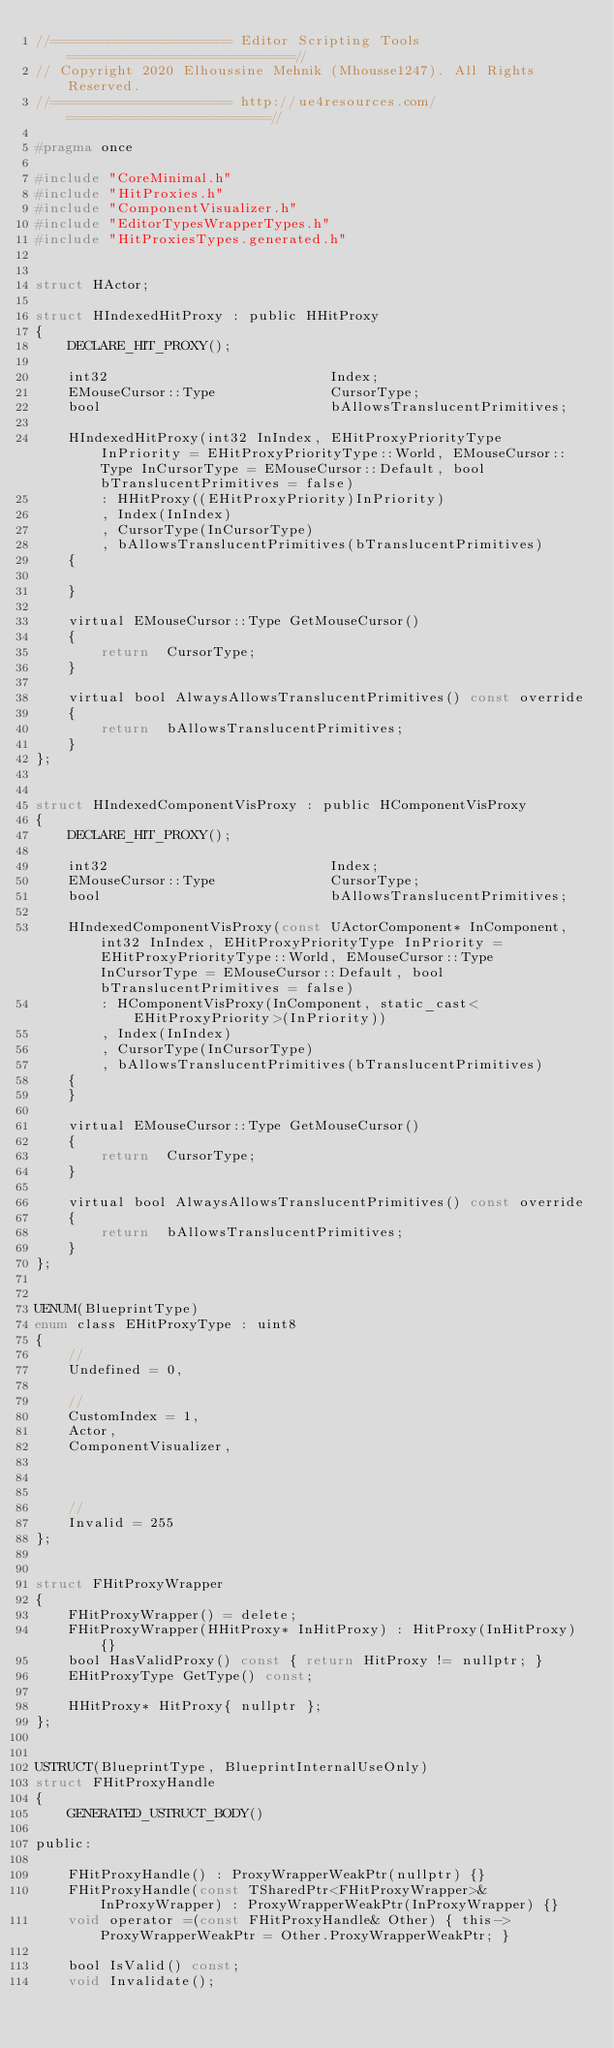Convert code to text. <code><loc_0><loc_0><loc_500><loc_500><_C_>//====================== Editor Scripting Tools ===========================//
// Copyright 2020 Elhoussine Mehnik (Mhousse1247). All Rights Reserved.
//====================== http://ue4resources.com/ ========================//

#pragma once

#include "CoreMinimal.h"
#include "HitProxies.h"
#include "ComponentVisualizer.h"
#include "EditorTypesWrapperTypes.h"
#include "HitProxiesTypes.generated.h"


struct HActor;

struct HIndexedHitProxy : public HHitProxy
{
	DECLARE_HIT_PROXY();

	int32							Index;
	EMouseCursor::Type				CursorType;
	bool							bAllowsTranslucentPrimitives;

	HIndexedHitProxy(int32 InIndex, EHitProxyPriorityType InPriority = EHitProxyPriorityType::World, EMouseCursor::Type InCursorType = EMouseCursor::Default, bool bTranslucentPrimitives = false)
		: HHitProxy((EHitProxyPriority)InPriority)
		, Index(InIndex)
		, CursorType(InCursorType)
		, bAllowsTranslucentPrimitives(bTranslucentPrimitives)
	{

	}

	virtual EMouseCursor::Type GetMouseCursor()
	{
		return  CursorType;
	}

	virtual bool AlwaysAllowsTranslucentPrimitives() const override
	{
		return  bAllowsTranslucentPrimitives;
	}
};


struct HIndexedComponentVisProxy : public HComponentVisProxy
{
	DECLARE_HIT_PROXY();

	int32							Index;
	EMouseCursor::Type				CursorType;
	bool							bAllowsTranslucentPrimitives;

	HIndexedComponentVisProxy(const UActorComponent* InComponent, int32 InIndex, EHitProxyPriorityType InPriority = EHitProxyPriorityType::World, EMouseCursor::Type InCursorType = EMouseCursor::Default, bool bTranslucentPrimitives = false)
		: HComponentVisProxy(InComponent, static_cast<EHitProxyPriority>(InPriority))
		, Index(InIndex)
		, CursorType(InCursorType)
		, bAllowsTranslucentPrimitives(bTranslucentPrimitives)
	{
	}

	virtual EMouseCursor::Type GetMouseCursor()
	{
		return  CursorType;
	}

	virtual bool AlwaysAllowsTranslucentPrimitives() const override
	{
		return  bAllowsTranslucentPrimitives;
	}
};


UENUM(BlueprintType)
enum class EHitProxyType : uint8
{
	//
	Undefined = 0,

	//
	CustomIndex = 1,
	Actor,
	ComponentVisualizer,



	//
	Invalid = 255
};


struct FHitProxyWrapper
{
	FHitProxyWrapper() = delete;
	FHitProxyWrapper(HHitProxy* InHitProxy) : HitProxy(InHitProxy) {}
	bool HasValidProxy() const { return HitProxy != nullptr; }
	EHitProxyType GetType() const;

	HHitProxy* HitProxy{ nullptr };
};


USTRUCT(BlueprintType, BlueprintInternalUseOnly)
struct FHitProxyHandle
{
	GENERATED_USTRUCT_BODY()

public:

	FHitProxyHandle() : ProxyWrapperWeakPtr(nullptr) {}
	FHitProxyHandle(const TSharedPtr<FHitProxyWrapper>& InProxyWrapper) : ProxyWrapperWeakPtr(InProxyWrapper) {}
	void operator =(const FHitProxyHandle& Other) { this->ProxyWrapperWeakPtr = Other.ProxyWrapperWeakPtr; }

	bool IsValid() const;
	void Invalidate();</code> 